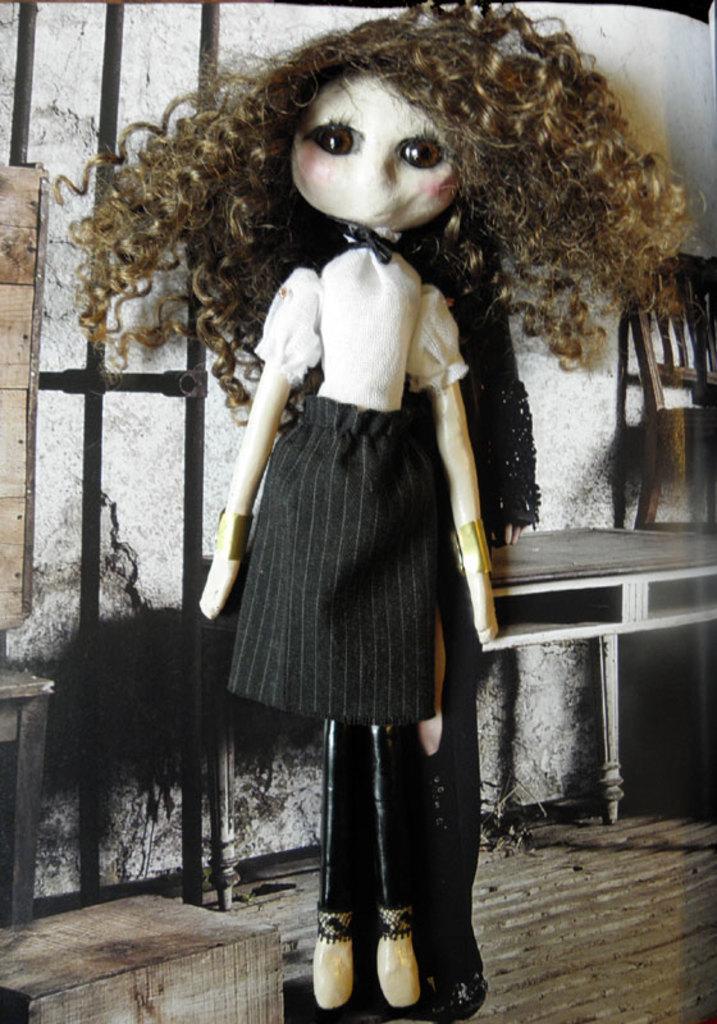Please provide a concise description of this image. Here in this picture we can see a doll present over there and its hair is messy and behind her we can see a table and a chair present over there. 